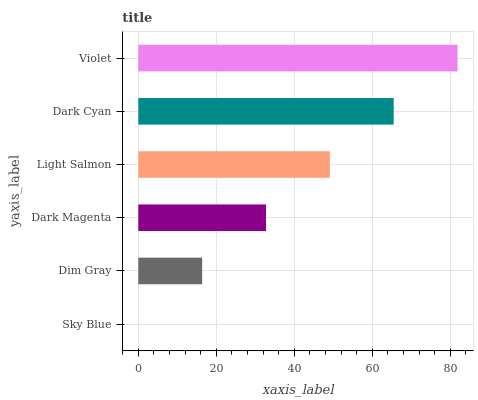Is Sky Blue the minimum?
Answer yes or no. Yes. Is Violet the maximum?
Answer yes or no. Yes. Is Dim Gray the minimum?
Answer yes or no. No. Is Dim Gray the maximum?
Answer yes or no. No. Is Dim Gray greater than Sky Blue?
Answer yes or no. Yes. Is Sky Blue less than Dim Gray?
Answer yes or no. Yes. Is Sky Blue greater than Dim Gray?
Answer yes or no. No. Is Dim Gray less than Sky Blue?
Answer yes or no. No. Is Light Salmon the high median?
Answer yes or no. Yes. Is Dark Magenta the low median?
Answer yes or no. Yes. Is Violet the high median?
Answer yes or no. No. Is Dim Gray the low median?
Answer yes or no. No. 